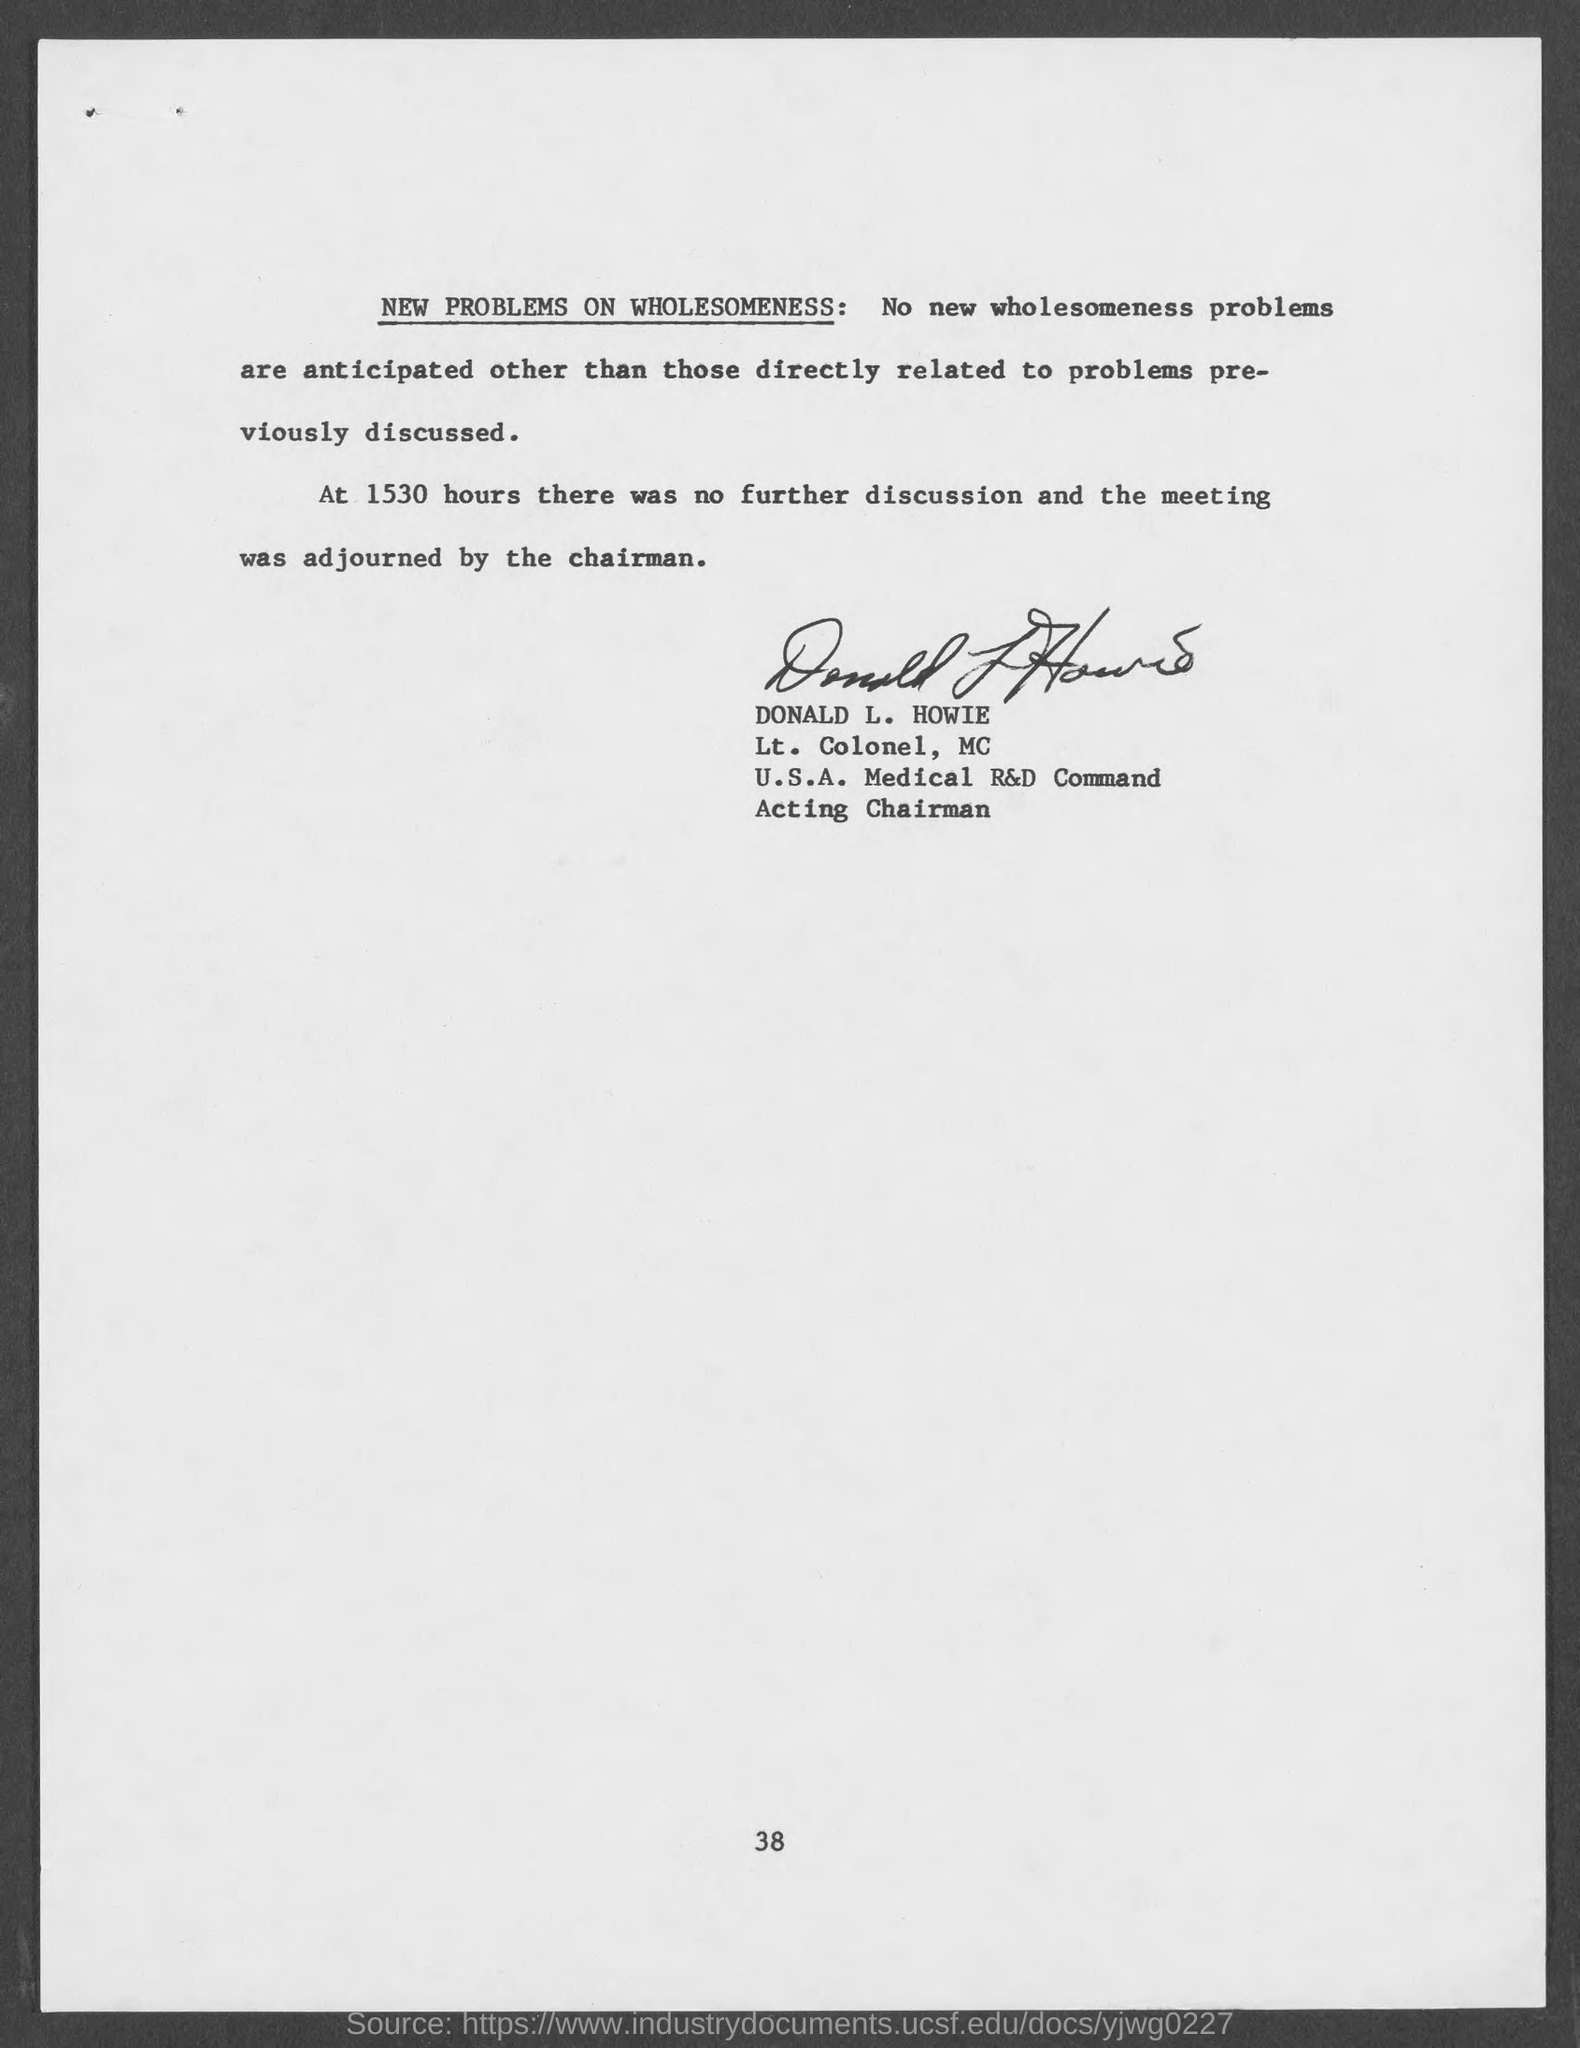What is the page number at bottom of the page?
Your answer should be very brief. 38. What is the military rank of donald l. howie?
Provide a short and direct response. Lt. Colonel, MC. 